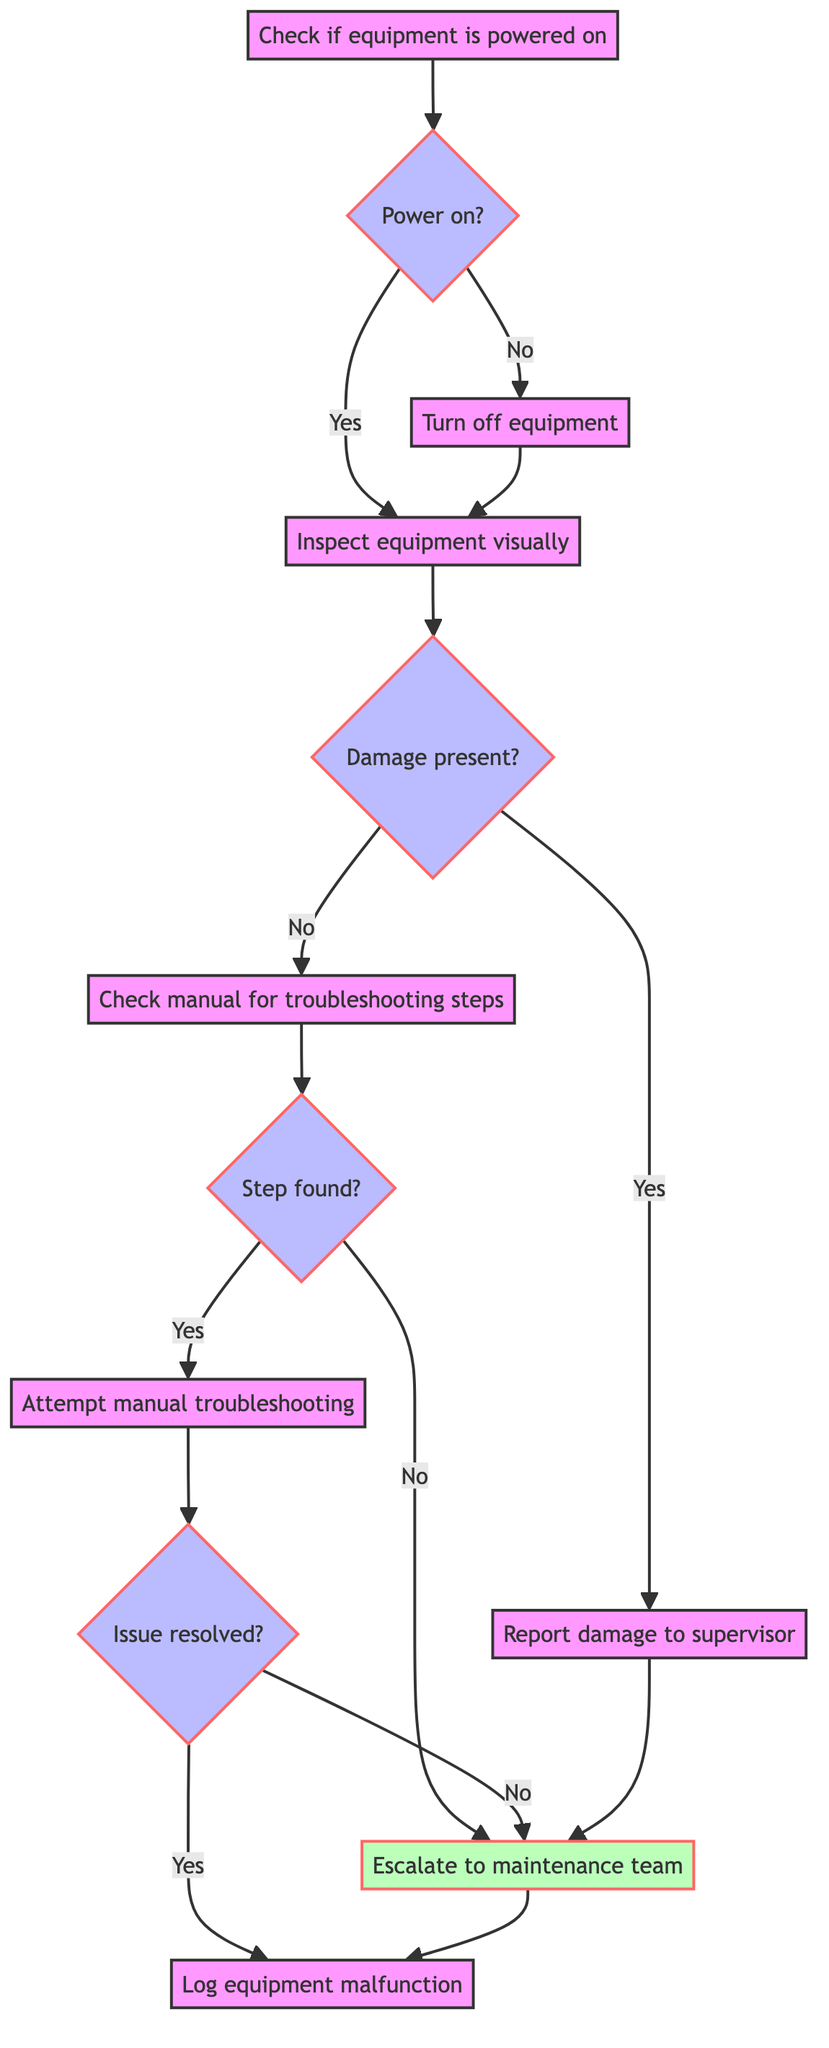What is the first step in the flowchart? The diagram starts with the step "Check if the equipment is powered on," which is the initial action taken before any other steps.
Answer: Check if the equipment is powered on How many decision nodes are present in the diagram? The diagram contains four decision nodes, which are the steps that require a yes or no answer: "Power on?", "Damage present?", "Step found?", and "Issue resolved?".
Answer: Four What happens if the manual troubleshooting step does not resolve the issue? If the manual troubleshooting step does not resolve the issue (IssueNotResolved), the flowchart leads to "Escalate to maintenance team," indicating the next course of action.
Answer: Escalate to maintenance team What is the output of the step "Inspect equipment visually"? The step "Inspect equipment visually" has two potential outputs: DamagePresent and NoDamage, indicating whether any visible issues were found on the equipment.
Answer: DamagePresent, NoDamage What will be the final step if there is no damage found and troubleshooting steps are available? If there is no damage found and troubleshooting steps are available, the final action after attempting manual troubleshooting will be to "Log equipment malfunction," regardless of whether the issue was resolved.
Answer: Log equipment malfunction What step should be taken if the equipment is not powered on? If the equipment is not powered on, the next step to be taken is "Turn off equipment," which will safely power down the machine before proceeding to the next checks.
Answer: Turn off equipment What is the output after visually inspecting the equipment if damage is present? If damage is present after visually inspecting the equipment, the next action is to "Report damage to supervisor," which is the output of the step.
Answer: Report damage to supervisor What leads to "Attempt manual troubleshooting"? "Attempt manual troubleshooting" is initiated if, after visually inspecting the equipment, no damage is found and there are troubleshooting steps available as indicated by "Step found?" decision node's yes answer.
Answer: Attempt manual troubleshooting 